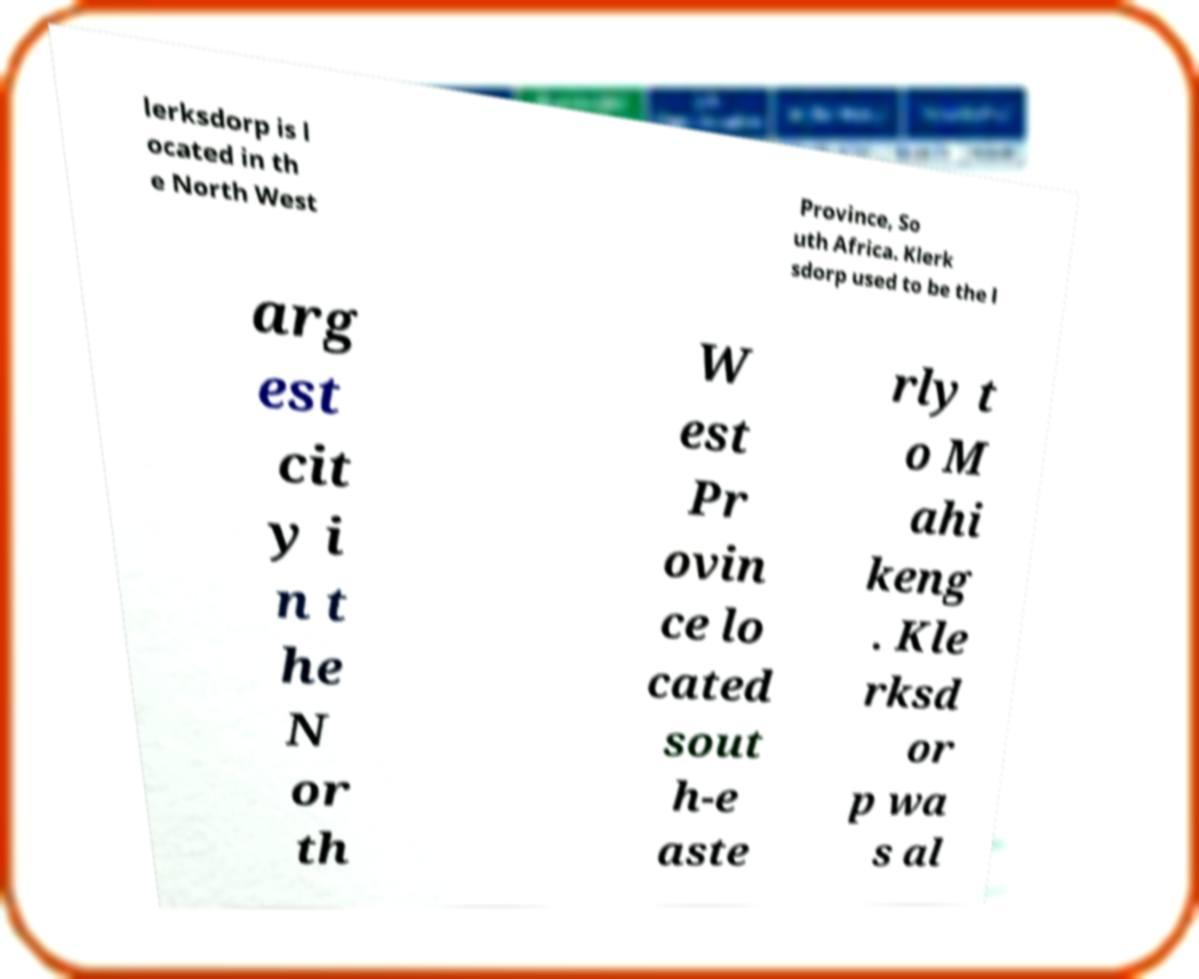There's text embedded in this image that I need extracted. Can you transcribe it verbatim? lerksdorp is l ocated in th e North West Province, So uth Africa. Klerk sdorp used to be the l arg est cit y i n t he N or th W est Pr ovin ce lo cated sout h-e aste rly t o M ahi keng . Kle rksd or p wa s al 